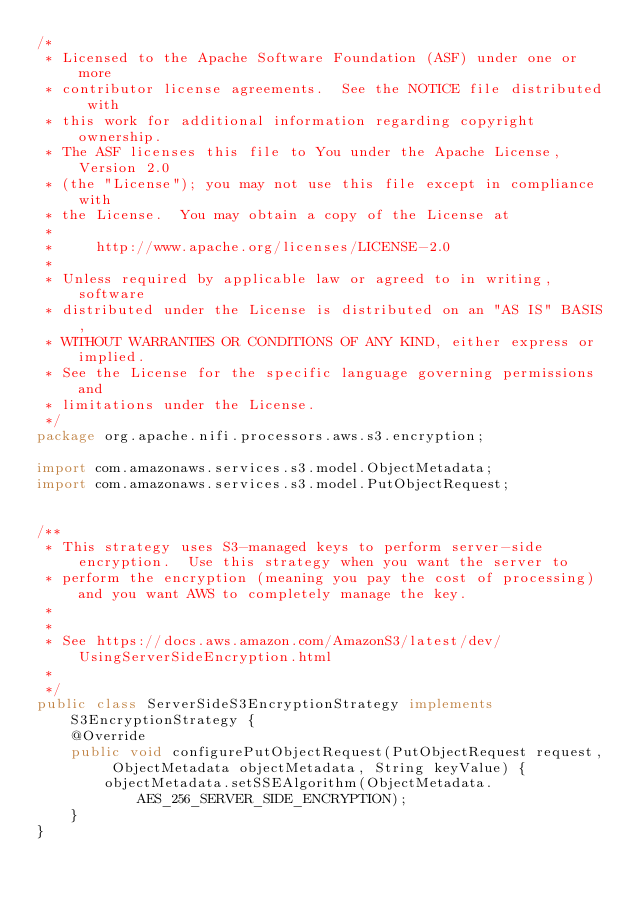Convert code to text. <code><loc_0><loc_0><loc_500><loc_500><_Java_>/*
 * Licensed to the Apache Software Foundation (ASF) under one or more
 * contributor license agreements.  See the NOTICE file distributed with
 * this work for additional information regarding copyright ownership.
 * The ASF licenses this file to You under the Apache License, Version 2.0
 * (the "License"); you may not use this file except in compliance with
 * the License.  You may obtain a copy of the License at
 *
 *     http://www.apache.org/licenses/LICENSE-2.0
 *
 * Unless required by applicable law or agreed to in writing, software
 * distributed under the License is distributed on an "AS IS" BASIS,
 * WITHOUT WARRANTIES OR CONDITIONS OF ANY KIND, either express or implied.
 * See the License for the specific language governing permissions and
 * limitations under the License.
 */
package org.apache.nifi.processors.aws.s3.encryption;

import com.amazonaws.services.s3.model.ObjectMetadata;
import com.amazonaws.services.s3.model.PutObjectRequest;


/**
 * This strategy uses S3-managed keys to perform server-side encryption.  Use this strategy when you want the server to
 * perform the encryption (meaning you pay the cost of processing) and you want AWS to completely manage the key.
 *
 *
 * See https://docs.aws.amazon.com/AmazonS3/latest/dev/UsingServerSideEncryption.html
 *
 */
public class ServerSideS3EncryptionStrategy implements S3EncryptionStrategy {
    @Override
    public void configurePutObjectRequest(PutObjectRequest request, ObjectMetadata objectMetadata, String keyValue) {
        objectMetadata.setSSEAlgorithm(ObjectMetadata.AES_256_SERVER_SIDE_ENCRYPTION);
    }
}
</code> 